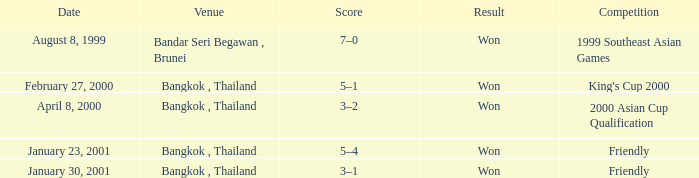In which contest was a match held with a score of 3-1? Friendly. 